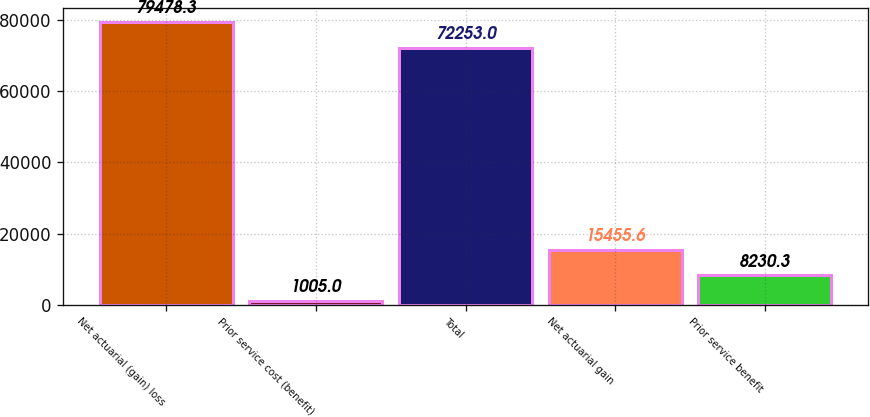Convert chart to OTSL. <chart><loc_0><loc_0><loc_500><loc_500><bar_chart><fcel>Net actuarial (gain) loss<fcel>Prior service cost (benefit)<fcel>Total<fcel>Net actuarial gain<fcel>Prior service benefit<nl><fcel>79478.3<fcel>1005<fcel>72253<fcel>15455.6<fcel>8230.3<nl></chart> 